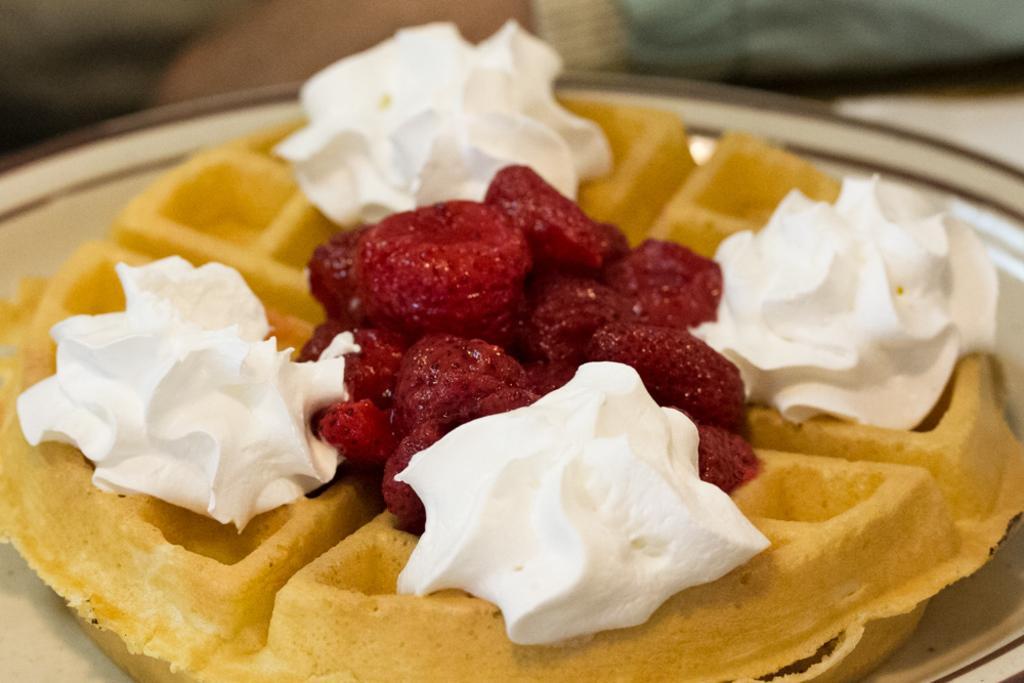Could you give a brief overview of what you see in this image? In the image there is a dessert prepared with waffles. 